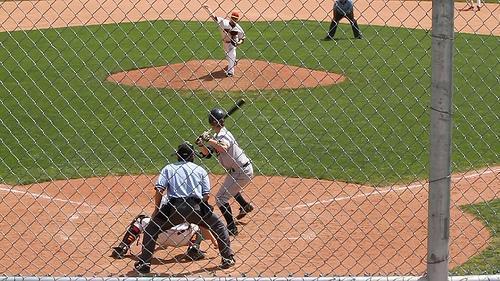How many baseball players are on the field?
Give a very brief answer. 3. 